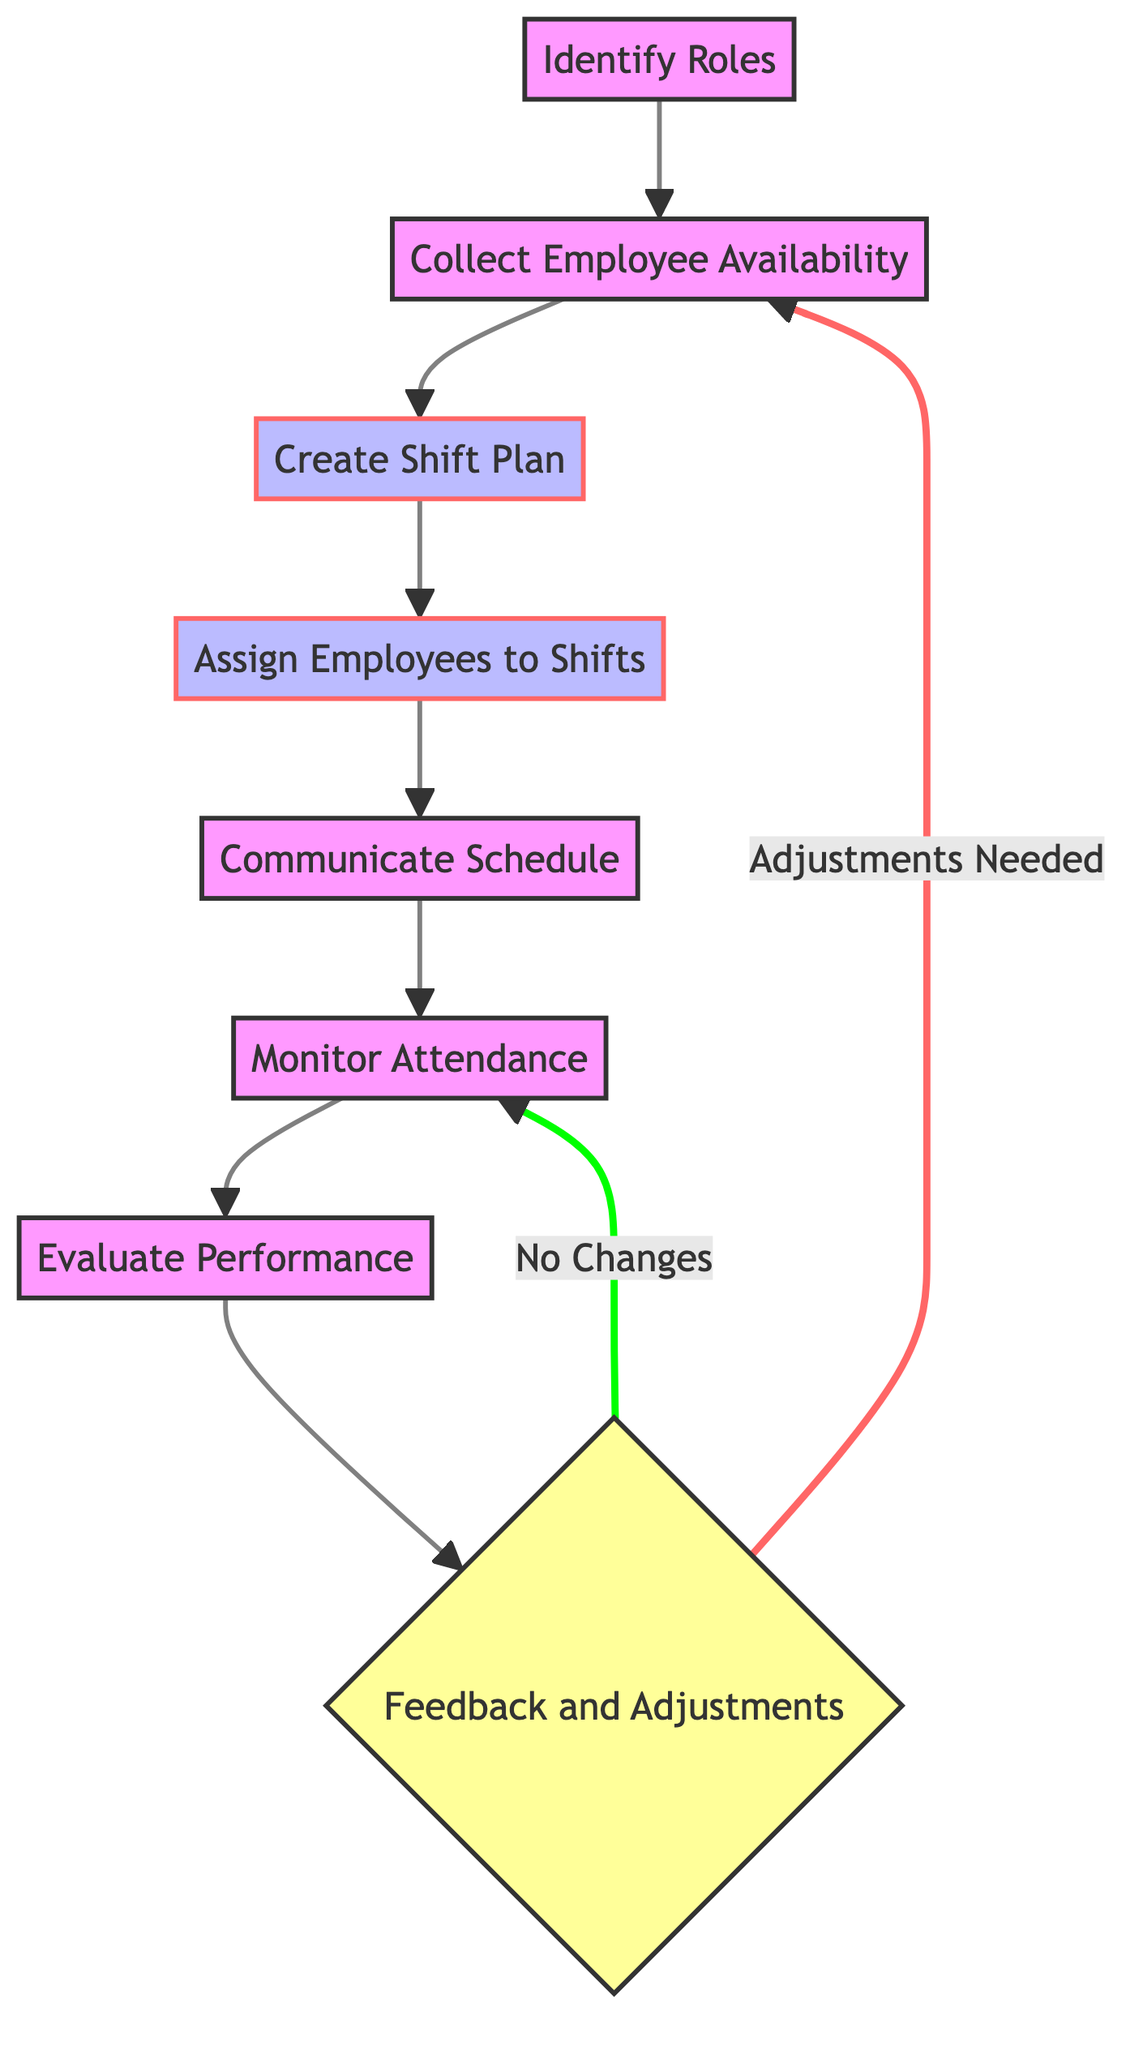What is the first step in the employee scheduling process? The first step is represented by the node "Identify Roles," which focuses on defining specific roles within the jewelry shop.
Answer: Identify Roles How many nodes are there in the diagram? The diagram contains a total of eight nodes, each representing a different step in the employee scheduling process.
Answer: Eight What is the last step before the feedback loop? The last step is "Evaluate Performance," which assesses employee performance regularly.
Answer: Evaluate Performance Which node directly follows "Create Shift Plan"? The next node that follows "Create Shift Plan" is "Assign Employees to Shifts," indicating that after planning shifts, employees are assigned.
Answer: Assign Employees to Shifts What happens if the feedback indicates adjustments are needed? If adjustments are needed, the flow returns to "Collect Employee Availability," indicating a revisiting of employee preferences and restrictions.
Answer: Collect Employee Availability How many decision nodes are present in the flowchart? There is one decision node in the flowchart, which is "Feedback and Adjustments."
Answer: One Which node communicates the finalized schedule to employees? The node "Communicate Schedule" is responsible for sharing the finalized schedule with all employees.
Answer: Communicate Schedule What follows monitoring attendance in the process? After "Monitor Attendance," the process moves to "Evaluate Performance," indicating a focus on assessing the performance of employees.
Answer: Evaluate Performance What is the main focus of the "Evaluate Performance" node? The main focus of this node is to assess employee performance based on criteria like punctuality, task completion, and customer service.
Answer: Assess employee performance 